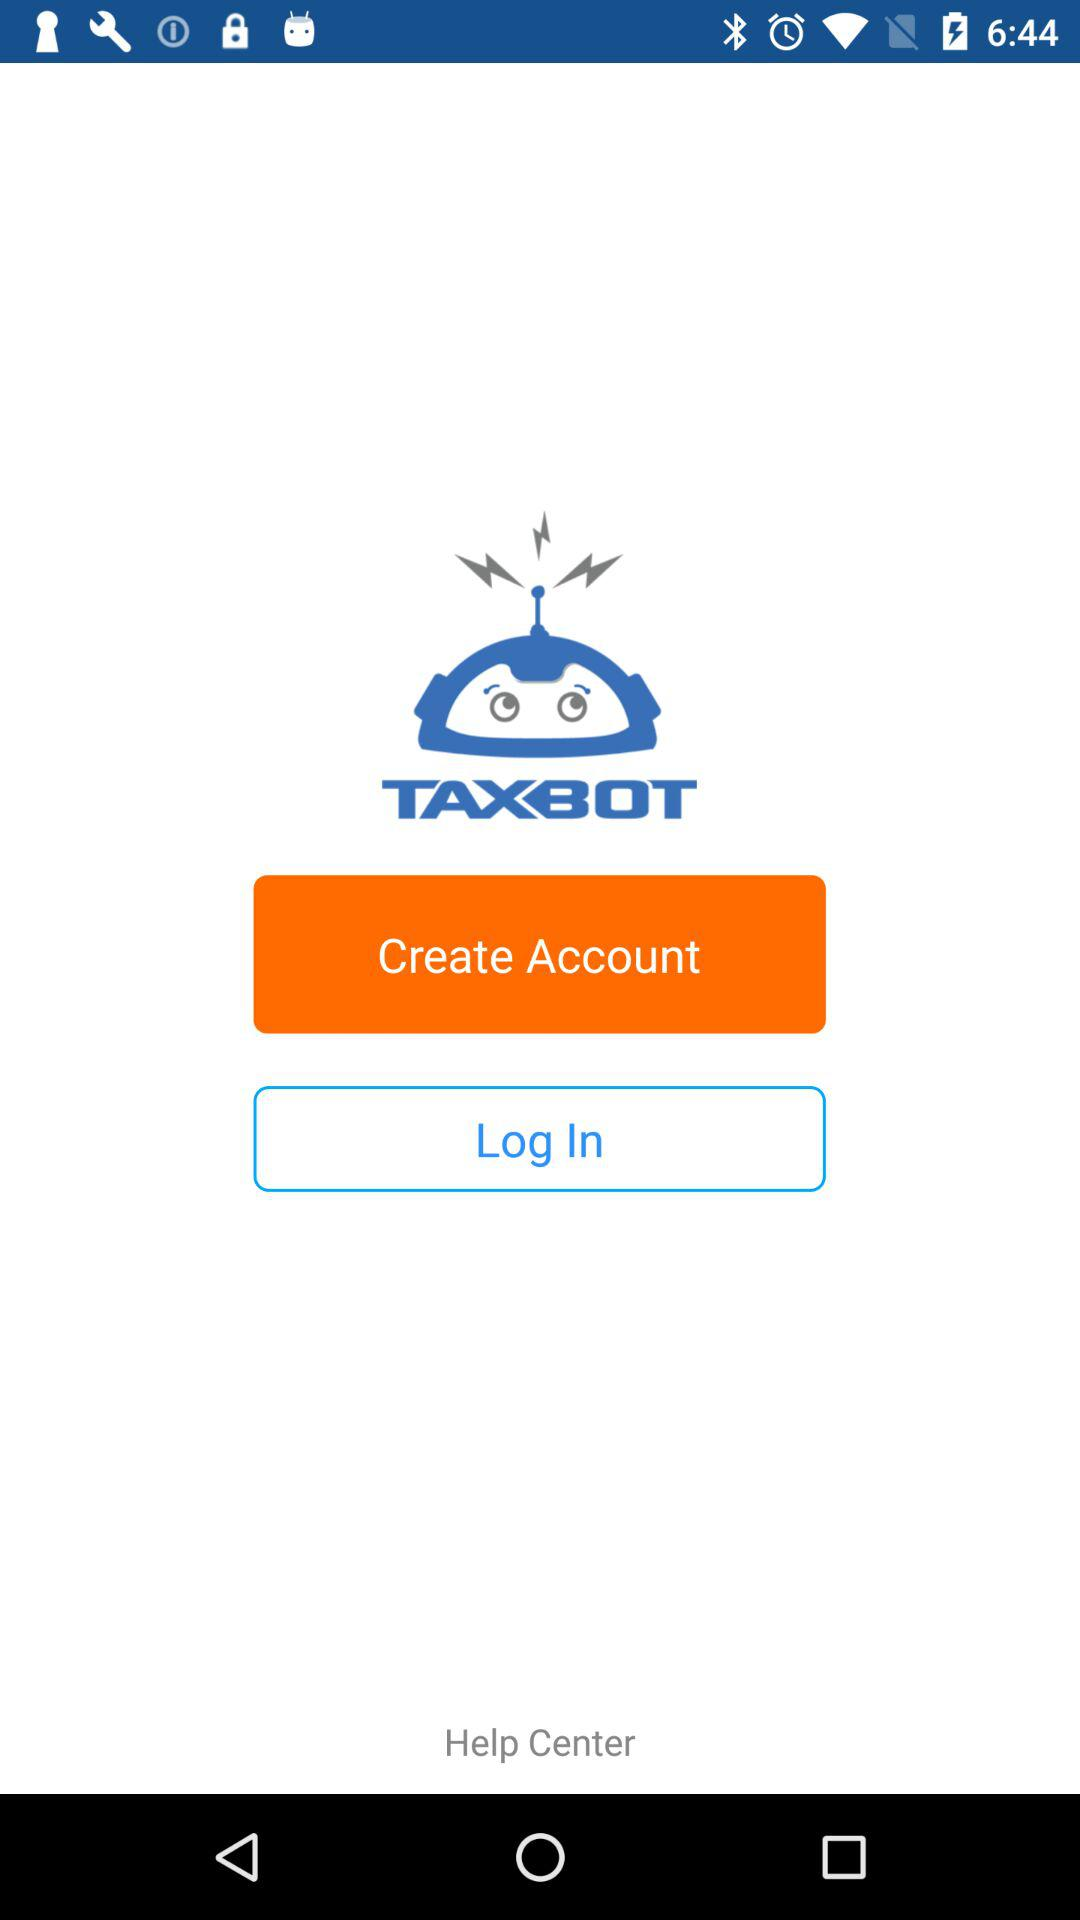To what application can we log in? You can log in to "TAXBOT". 